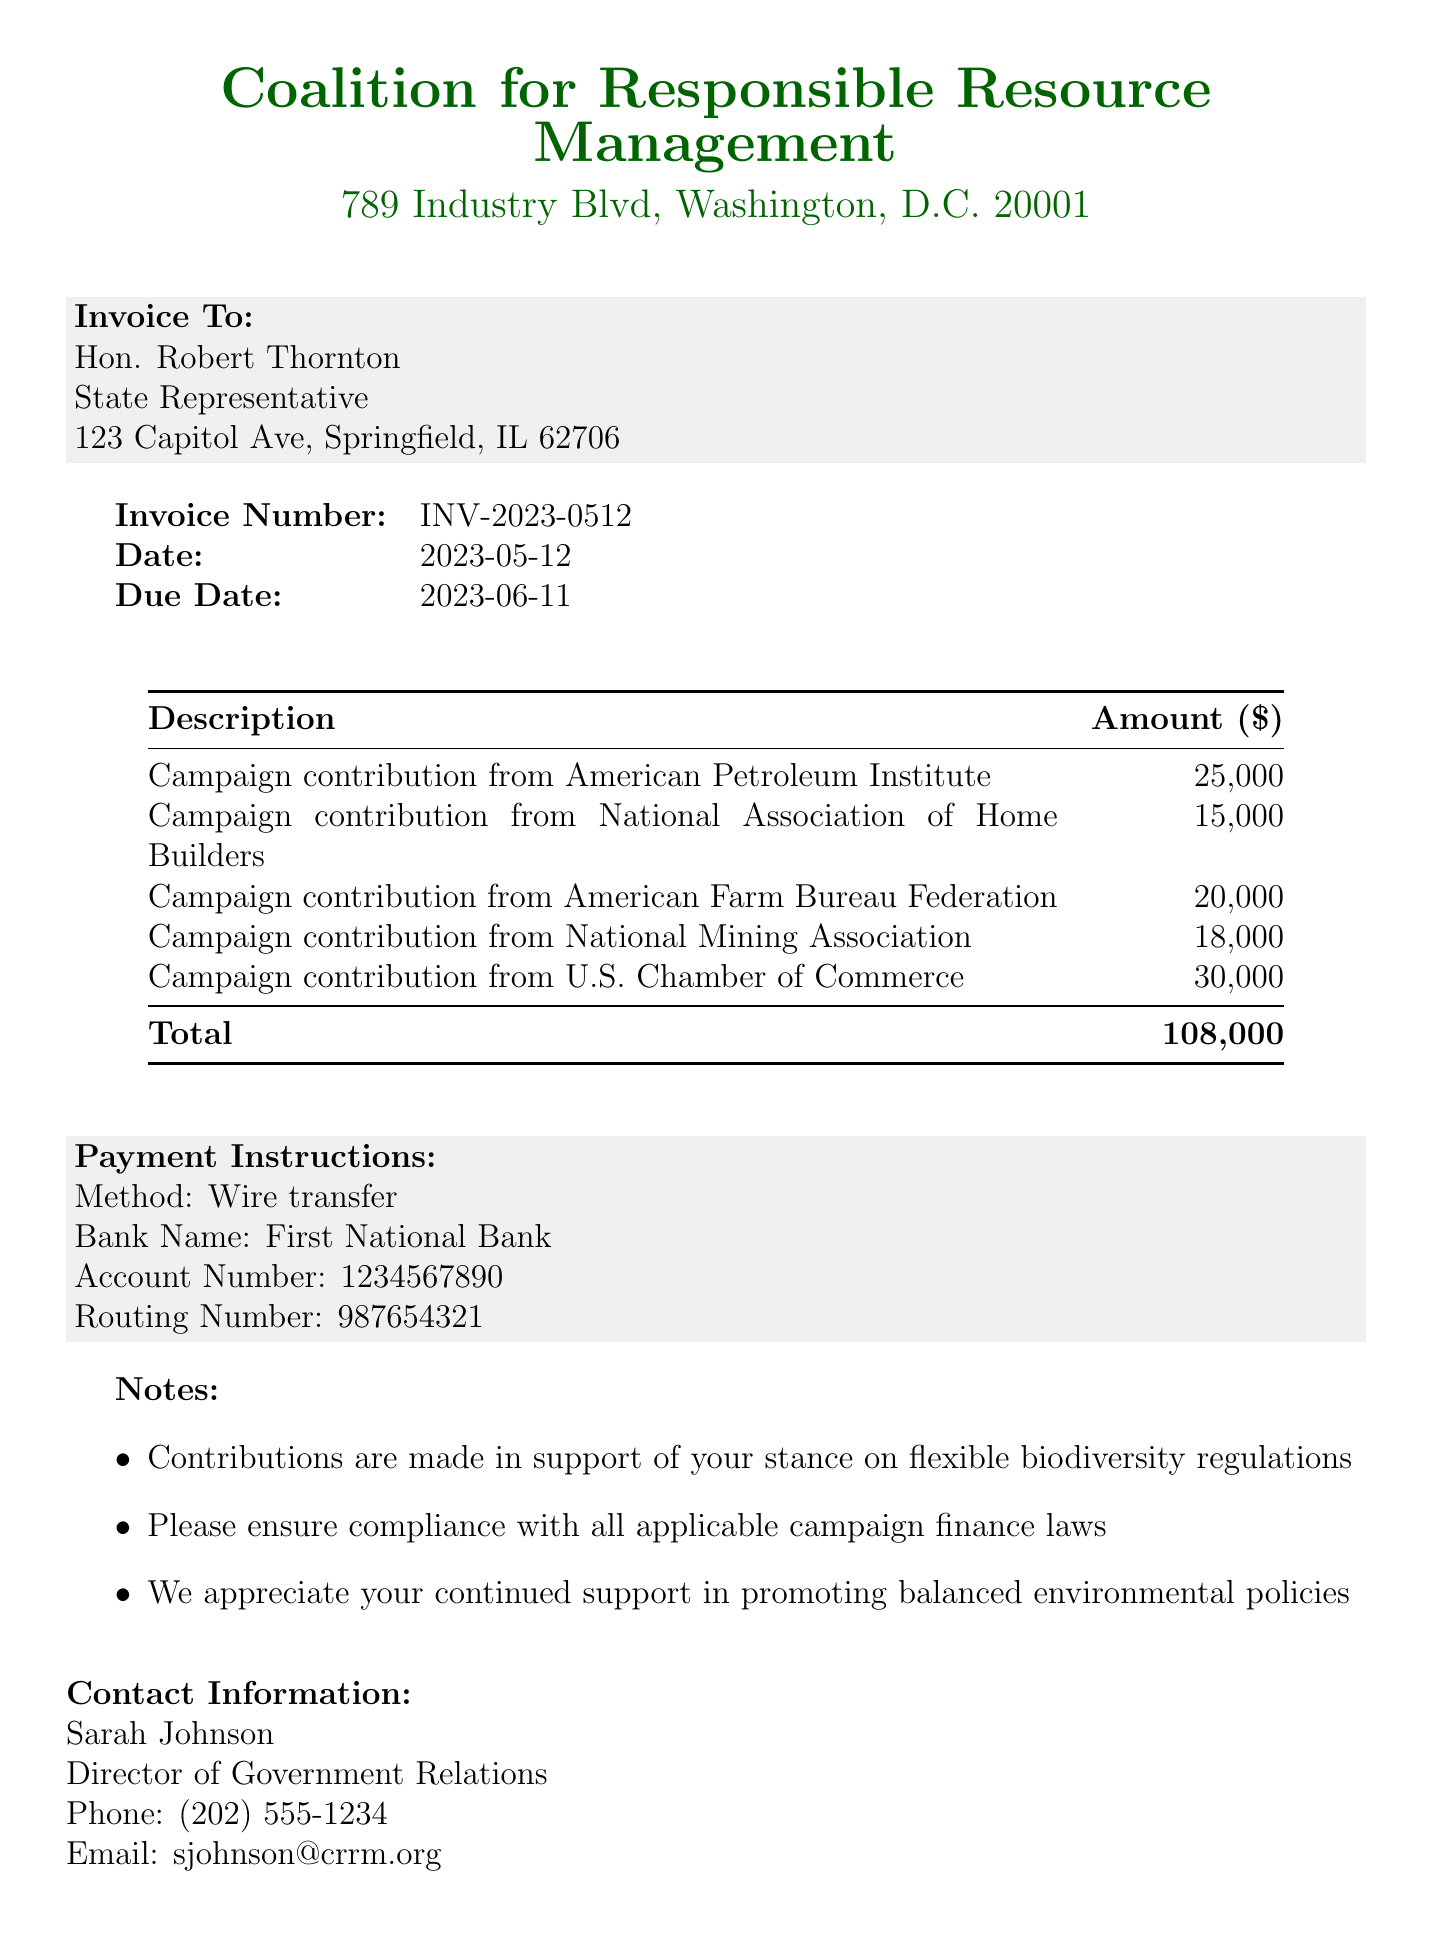what is the invoice number? The invoice number is explicitly listed at the top of the document.
Answer: INV-2023-0512 who is the invoice billed to? The document specifies the name and position of the recipient of the invoice.
Answer: Hon. Robert Thornton what is the total amount of the invoice? The total amount is calculated based on the sum of all campaign contributions listed in the document.
Answer: 108000 when is the payment due? The due date for payment is clearly indicated in the document.
Answer: 2023-06-11 how many campaign contributions are listed in the invoice? The number of contributions can be determined by counting the individual items in the list.
Answer: 5 what is one of the notes mentioned in the invoice? Specific notes are provided at the end of the invoice, highlighting the purpose of contributions.
Answer: Contributions are made in support of your stance on flexible biodiversity regulations which organization sent the invoice? The invoice specifies the name of the organization from which it originates.
Answer: Coalition for Responsible Resource Management what payment method is requested? The document includes specific instructions regarding how payments should be made.
Answer: Wire transfer who can be contacted for more information? The contact information section lists the individual responsible for inquiries.
Answer: Sarah Johnson 